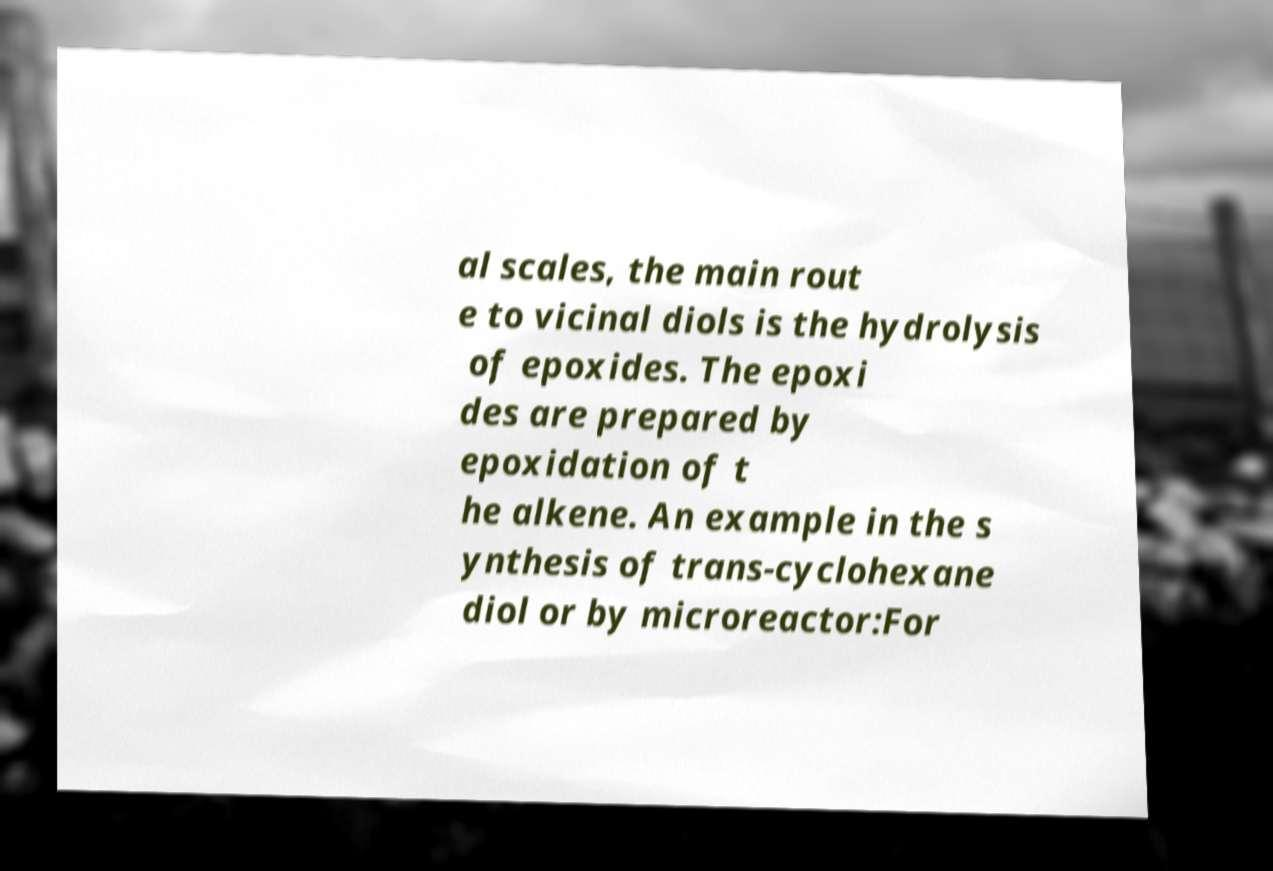Can you accurately transcribe the text from the provided image for me? al scales, the main rout e to vicinal diols is the hydrolysis of epoxides. The epoxi des are prepared by epoxidation of t he alkene. An example in the s ynthesis of trans-cyclohexane diol or by microreactor:For 